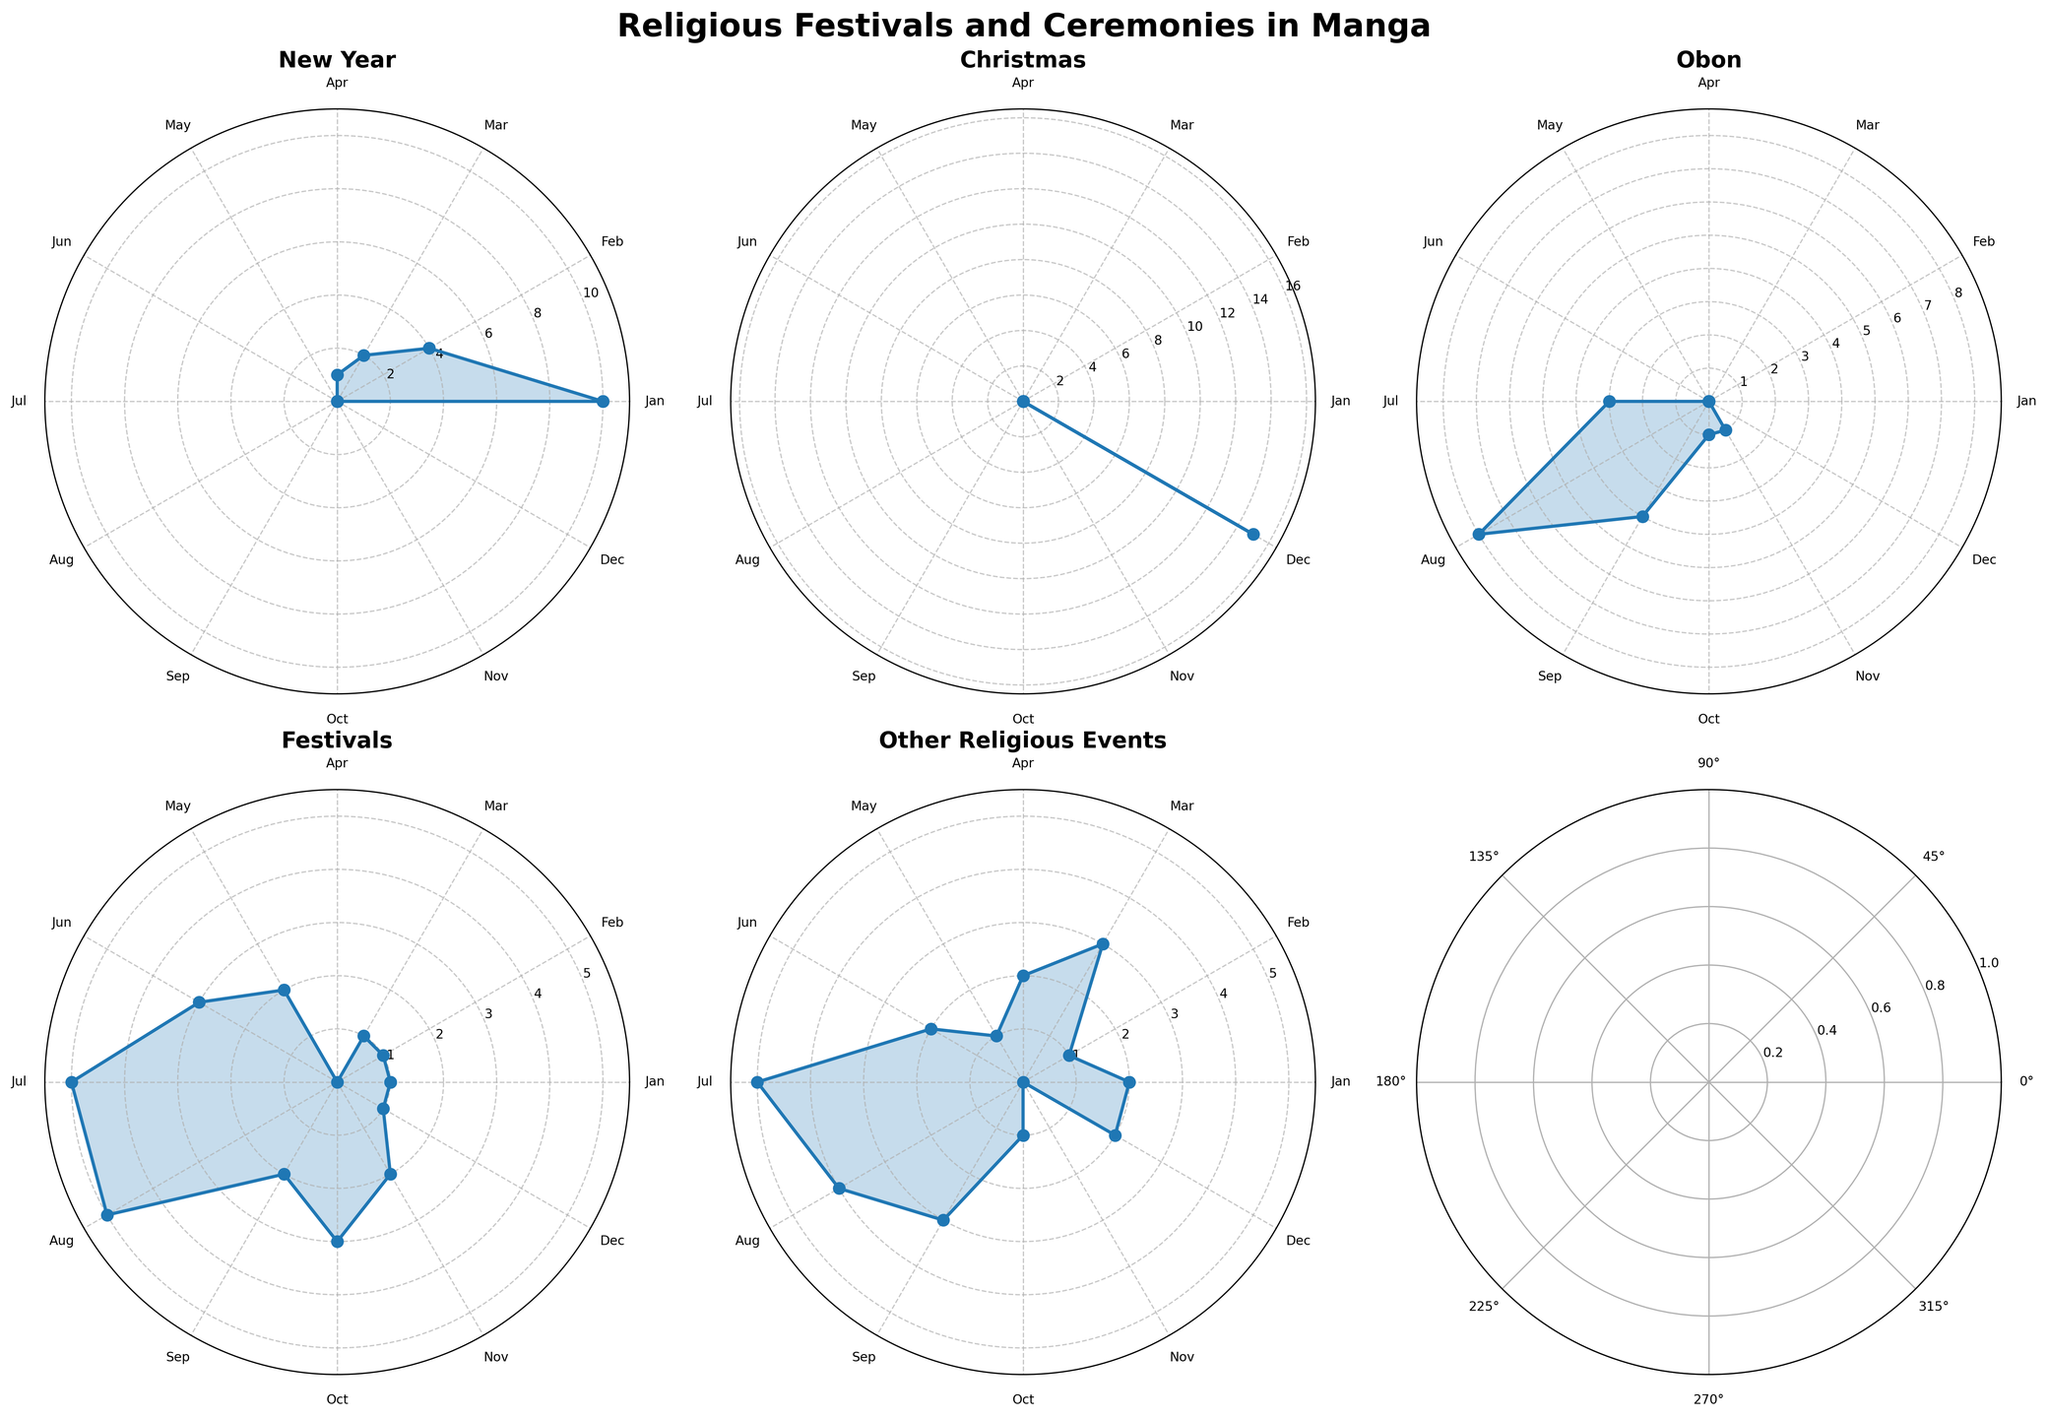What is the title of the figure? The title is located at the top center of the figure and reads "Religious Festivals and Ceremonies in Manga".
Answer: Religious Festivals and Ceremonies in Manga Which month shows the highest frequency of New Year festivals? Refer to the subplot for New Year festivals. The highest frequency is when the value peaks. Here, it peaks in January.
Answer: January Which event has the highest frequency number in December? Refer to the Christmas subplot for December. The Christmas subplot shows a peak value of 15.
Answer: Christmas What is the frequency difference of Obon between July and August? Look at the Obon subplot and compare the values in July and August: July has a frequency of 3 and August has 8. Subtract 3 from 8 to find the difference.
Answer: 5 Which event has the most even distribution throughout the year? Look at all subplots and observe frequency variations throughout the year. 'Other Religious Events' has relatively smaller and more evenly distributed variations compared to other events.
Answer: Other Religious Events Which two months show the highest combined frequency for Festivals? Refer to the Festivals subplot. Identify the values in all months and find the two months with the highest values. July and August have values of 5 each, making their combined frequency 10.
Answer: July and August In which month does Obon appear and how frequently? Refer to the Obon subplot and observe the values for each month. Obon appears in July, August, September, October, and November with the frequencies, respectively: 3, 8, 4, 1, and 1.
Answer: July, August, September, October, November What is the combined total frequency of all events in January? Sum the values from each subplot for January: New Year (10), Christmas (0), Obon (0), Festivals (1), Other Religious Events (2). 10 + 0 + 0 + 1 + 2 = 13.
Answer: 13 How many months show any frequency for Christmas events? Refer to the Christmas subplot and count the months with a non-zero frequency. Only December shows a frequency.
Answer: 1 What is the rate of frequency change for Festivals between June and July? Compare the values in Festivals subplot: June has a frequency of 3 and July has 5. The rate is the difference divided by the initial value: (5 - 3) / 3 ≈ 0.67.
Answer: 0.67 